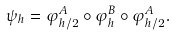Convert formula to latex. <formula><loc_0><loc_0><loc_500><loc_500>\psi _ { h } = \varphi _ { h / 2 } ^ { A } \circ \varphi _ { h } ^ { B } \circ \varphi _ { h / 2 } ^ { A } .</formula> 